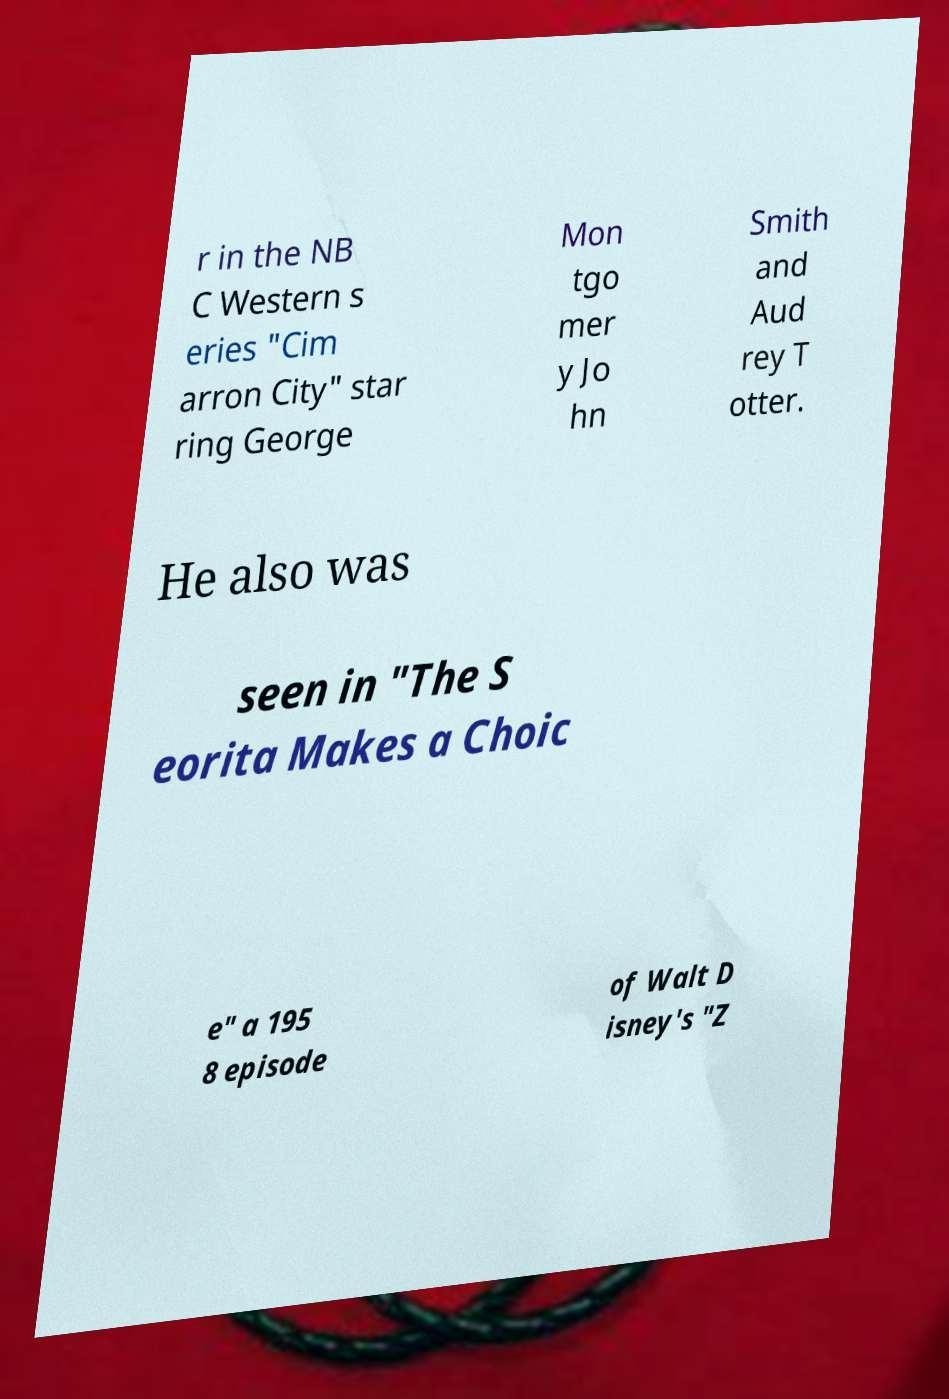Can you read and provide the text displayed in the image?This photo seems to have some interesting text. Can you extract and type it out for me? r in the NB C Western s eries "Cim arron City" star ring George Mon tgo mer y Jo hn Smith and Aud rey T otter. He also was seen in "The S eorita Makes a Choic e" a 195 8 episode of Walt D isney's "Z 